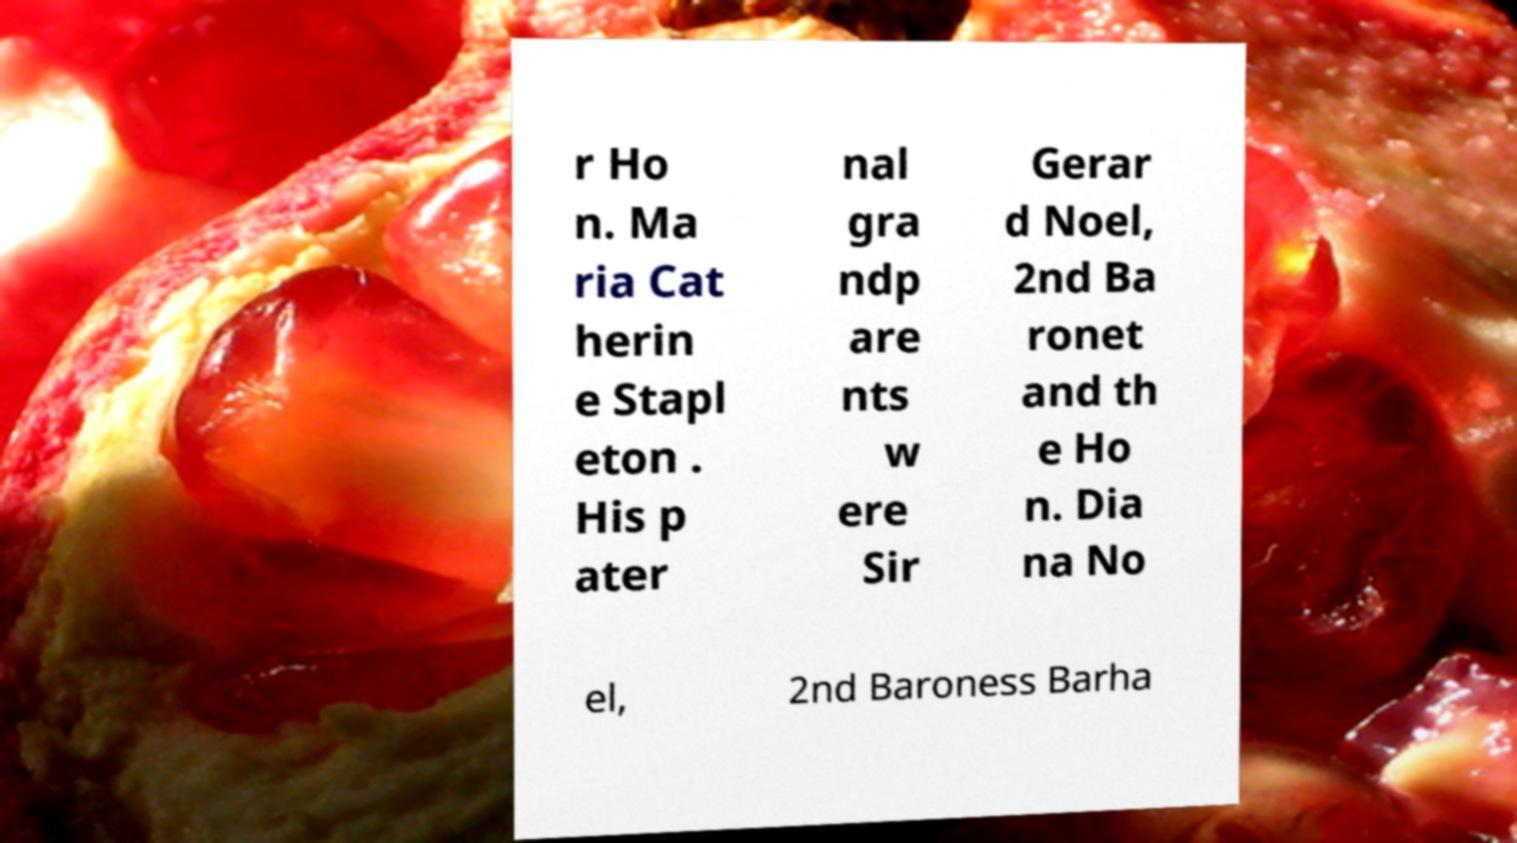Please identify and transcribe the text found in this image. r Ho n. Ma ria Cat herin e Stapl eton . His p ater nal gra ndp are nts w ere Sir Gerar d Noel, 2nd Ba ronet and th e Ho n. Dia na No el, 2nd Baroness Barha 